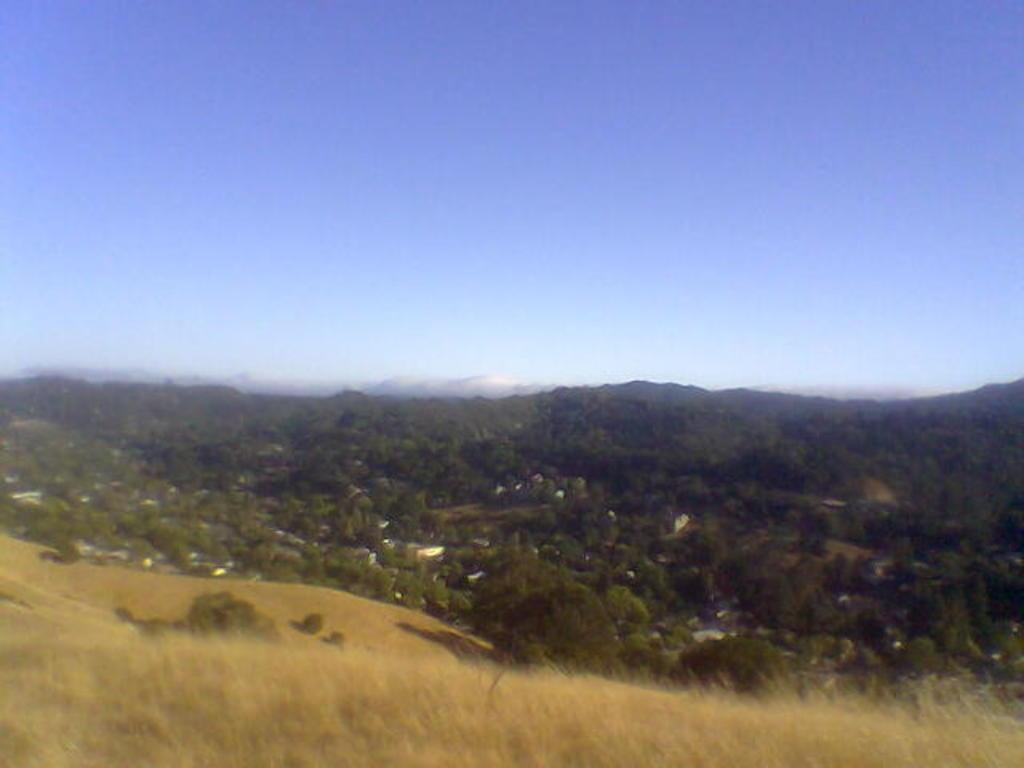How would you summarize this image in a sentence or two? In this image in front there is grass on the surface. In the background of the image there are trees, buildings, mountains and sky. 